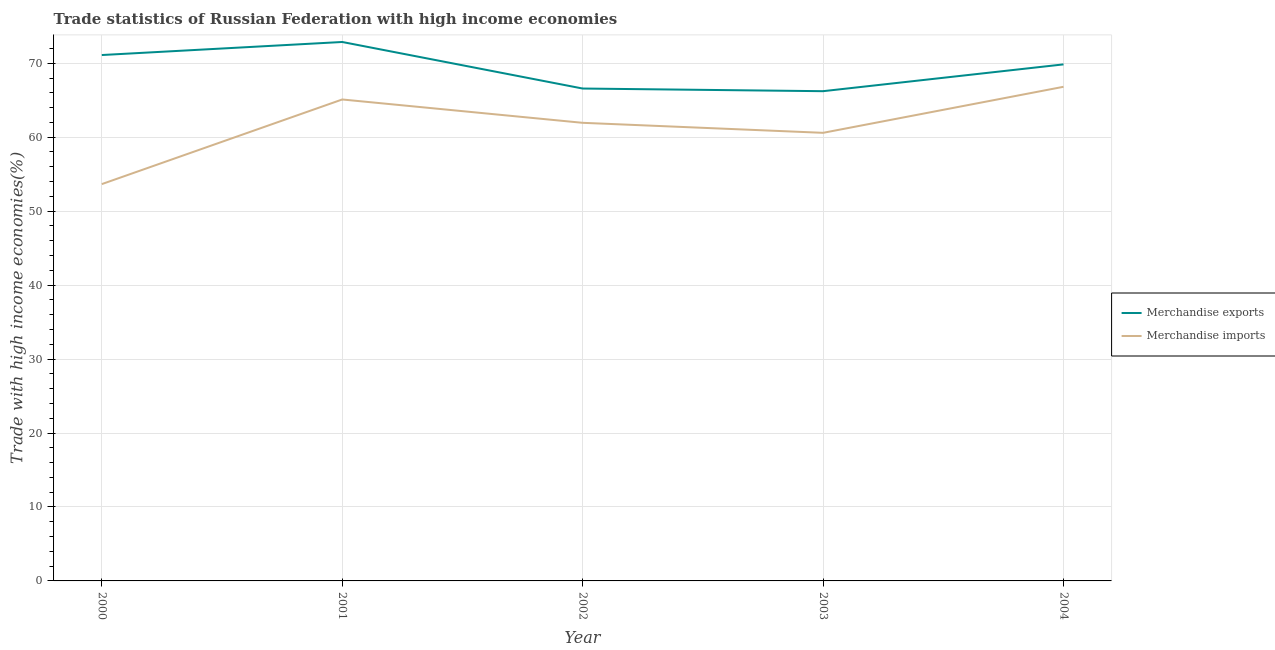How many different coloured lines are there?
Give a very brief answer. 2. What is the merchandise exports in 2002?
Your response must be concise. 66.58. Across all years, what is the maximum merchandise exports?
Your answer should be compact. 72.87. Across all years, what is the minimum merchandise imports?
Offer a terse response. 53.65. In which year was the merchandise exports maximum?
Your answer should be compact. 2001. What is the total merchandise imports in the graph?
Your answer should be very brief. 308.09. What is the difference between the merchandise exports in 2001 and that in 2004?
Keep it short and to the point. 3.03. What is the difference between the merchandise imports in 2000 and the merchandise exports in 2001?
Ensure brevity in your answer.  -19.22. What is the average merchandise imports per year?
Offer a very short reply. 61.62. In the year 2001, what is the difference between the merchandise exports and merchandise imports?
Make the answer very short. 7.77. In how many years, is the merchandise imports greater than 22 %?
Offer a very short reply. 5. What is the ratio of the merchandise imports in 2001 to that in 2004?
Provide a short and direct response. 0.97. Is the merchandise exports in 2000 less than that in 2003?
Ensure brevity in your answer.  No. What is the difference between the highest and the second highest merchandise exports?
Keep it short and to the point. 1.76. What is the difference between the highest and the lowest merchandise imports?
Your response must be concise. 13.16. Does the merchandise exports monotonically increase over the years?
Keep it short and to the point. No. Is the merchandise imports strictly greater than the merchandise exports over the years?
Make the answer very short. No. Is the merchandise imports strictly less than the merchandise exports over the years?
Provide a succinct answer. Yes. What is the difference between two consecutive major ticks on the Y-axis?
Keep it short and to the point. 10. Where does the legend appear in the graph?
Your response must be concise. Center right. How many legend labels are there?
Offer a terse response. 2. What is the title of the graph?
Ensure brevity in your answer.  Trade statistics of Russian Federation with high income economies. What is the label or title of the X-axis?
Offer a terse response. Year. What is the label or title of the Y-axis?
Your answer should be compact. Trade with high income economies(%). What is the Trade with high income economies(%) of Merchandise exports in 2000?
Provide a succinct answer. 71.11. What is the Trade with high income economies(%) of Merchandise imports in 2000?
Provide a succinct answer. 53.65. What is the Trade with high income economies(%) in Merchandise exports in 2001?
Your answer should be very brief. 72.87. What is the Trade with high income economies(%) of Merchandise imports in 2001?
Give a very brief answer. 65.1. What is the Trade with high income economies(%) of Merchandise exports in 2002?
Provide a succinct answer. 66.58. What is the Trade with high income economies(%) in Merchandise imports in 2002?
Your response must be concise. 61.94. What is the Trade with high income economies(%) in Merchandise exports in 2003?
Your answer should be very brief. 66.22. What is the Trade with high income economies(%) of Merchandise imports in 2003?
Your answer should be compact. 60.59. What is the Trade with high income economies(%) of Merchandise exports in 2004?
Give a very brief answer. 69.84. What is the Trade with high income economies(%) of Merchandise imports in 2004?
Make the answer very short. 66.81. Across all years, what is the maximum Trade with high income economies(%) in Merchandise exports?
Provide a succinct answer. 72.87. Across all years, what is the maximum Trade with high income economies(%) of Merchandise imports?
Your response must be concise. 66.81. Across all years, what is the minimum Trade with high income economies(%) in Merchandise exports?
Provide a short and direct response. 66.22. Across all years, what is the minimum Trade with high income economies(%) of Merchandise imports?
Offer a terse response. 53.65. What is the total Trade with high income economies(%) in Merchandise exports in the graph?
Make the answer very short. 346.61. What is the total Trade with high income economies(%) of Merchandise imports in the graph?
Provide a succinct answer. 308.09. What is the difference between the Trade with high income economies(%) of Merchandise exports in 2000 and that in 2001?
Offer a terse response. -1.76. What is the difference between the Trade with high income economies(%) of Merchandise imports in 2000 and that in 2001?
Make the answer very short. -11.44. What is the difference between the Trade with high income economies(%) of Merchandise exports in 2000 and that in 2002?
Provide a succinct answer. 4.53. What is the difference between the Trade with high income economies(%) of Merchandise imports in 2000 and that in 2002?
Offer a very short reply. -8.29. What is the difference between the Trade with high income economies(%) of Merchandise exports in 2000 and that in 2003?
Ensure brevity in your answer.  4.89. What is the difference between the Trade with high income economies(%) of Merchandise imports in 2000 and that in 2003?
Your response must be concise. -6.93. What is the difference between the Trade with high income economies(%) of Merchandise exports in 2000 and that in 2004?
Your response must be concise. 1.27. What is the difference between the Trade with high income economies(%) in Merchandise imports in 2000 and that in 2004?
Ensure brevity in your answer.  -13.16. What is the difference between the Trade with high income economies(%) in Merchandise exports in 2001 and that in 2002?
Make the answer very short. 6.29. What is the difference between the Trade with high income economies(%) in Merchandise imports in 2001 and that in 2002?
Your answer should be very brief. 3.16. What is the difference between the Trade with high income economies(%) in Merchandise exports in 2001 and that in 2003?
Offer a very short reply. 6.65. What is the difference between the Trade with high income economies(%) in Merchandise imports in 2001 and that in 2003?
Provide a short and direct response. 4.51. What is the difference between the Trade with high income economies(%) of Merchandise exports in 2001 and that in 2004?
Make the answer very short. 3.03. What is the difference between the Trade with high income economies(%) of Merchandise imports in 2001 and that in 2004?
Keep it short and to the point. -1.72. What is the difference between the Trade with high income economies(%) of Merchandise exports in 2002 and that in 2003?
Give a very brief answer. 0.36. What is the difference between the Trade with high income economies(%) of Merchandise imports in 2002 and that in 2003?
Make the answer very short. 1.35. What is the difference between the Trade with high income economies(%) of Merchandise exports in 2002 and that in 2004?
Offer a terse response. -3.26. What is the difference between the Trade with high income economies(%) in Merchandise imports in 2002 and that in 2004?
Keep it short and to the point. -4.87. What is the difference between the Trade with high income economies(%) of Merchandise exports in 2003 and that in 2004?
Ensure brevity in your answer.  -3.62. What is the difference between the Trade with high income economies(%) of Merchandise imports in 2003 and that in 2004?
Ensure brevity in your answer.  -6.22. What is the difference between the Trade with high income economies(%) in Merchandise exports in 2000 and the Trade with high income economies(%) in Merchandise imports in 2001?
Your answer should be compact. 6.01. What is the difference between the Trade with high income economies(%) in Merchandise exports in 2000 and the Trade with high income economies(%) in Merchandise imports in 2002?
Make the answer very short. 9.17. What is the difference between the Trade with high income economies(%) of Merchandise exports in 2000 and the Trade with high income economies(%) of Merchandise imports in 2003?
Offer a very short reply. 10.52. What is the difference between the Trade with high income economies(%) in Merchandise exports in 2000 and the Trade with high income economies(%) in Merchandise imports in 2004?
Ensure brevity in your answer.  4.29. What is the difference between the Trade with high income economies(%) in Merchandise exports in 2001 and the Trade with high income economies(%) in Merchandise imports in 2002?
Keep it short and to the point. 10.93. What is the difference between the Trade with high income economies(%) of Merchandise exports in 2001 and the Trade with high income economies(%) of Merchandise imports in 2003?
Keep it short and to the point. 12.28. What is the difference between the Trade with high income economies(%) of Merchandise exports in 2001 and the Trade with high income economies(%) of Merchandise imports in 2004?
Offer a very short reply. 6.06. What is the difference between the Trade with high income economies(%) in Merchandise exports in 2002 and the Trade with high income economies(%) in Merchandise imports in 2003?
Provide a short and direct response. 5.99. What is the difference between the Trade with high income economies(%) in Merchandise exports in 2002 and the Trade with high income economies(%) in Merchandise imports in 2004?
Your response must be concise. -0.24. What is the difference between the Trade with high income economies(%) in Merchandise exports in 2003 and the Trade with high income economies(%) in Merchandise imports in 2004?
Make the answer very short. -0.59. What is the average Trade with high income economies(%) in Merchandise exports per year?
Your answer should be compact. 69.32. What is the average Trade with high income economies(%) in Merchandise imports per year?
Give a very brief answer. 61.62. In the year 2000, what is the difference between the Trade with high income economies(%) of Merchandise exports and Trade with high income economies(%) of Merchandise imports?
Ensure brevity in your answer.  17.45. In the year 2001, what is the difference between the Trade with high income economies(%) in Merchandise exports and Trade with high income economies(%) in Merchandise imports?
Your answer should be very brief. 7.77. In the year 2002, what is the difference between the Trade with high income economies(%) of Merchandise exports and Trade with high income economies(%) of Merchandise imports?
Give a very brief answer. 4.64. In the year 2003, what is the difference between the Trade with high income economies(%) of Merchandise exports and Trade with high income economies(%) of Merchandise imports?
Keep it short and to the point. 5.63. In the year 2004, what is the difference between the Trade with high income economies(%) in Merchandise exports and Trade with high income economies(%) in Merchandise imports?
Make the answer very short. 3.03. What is the ratio of the Trade with high income economies(%) in Merchandise exports in 2000 to that in 2001?
Your answer should be very brief. 0.98. What is the ratio of the Trade with high income economies(%) of Merchandise imports in 2000 to that in 2001?
Your answer should be compact. 0.82. What is the ratio of the Trade with high income economies(%) in Merchandise exports in 2000 to that in 2002?
Make the answer very short. 1.07. What is the ratio of the Trade with high income economies(%) of Merchandise imports in 2000 to that in 2002?
Give a very brief answer. 0.87. What is the ratio of the Trade with high income economies(%) of Merchandise exports in 2000 to that in 2003?
Make the answer very short. 1.07. What is the ratio of the Trade with high income economies(%) in Merchandise imports in 2000 to that in 2003?
Your response must be concise. 0.89. What is the ratio of the Trade with high income economies(%) in Merchandise exports in 2000 to that in 2004?
Offer a terse response. 1.02. What is the ratio of the Trade with high income economies(%) of Merchandise imports in 2000 to that in 2004?
Offer a terse response. 0.8. What is the ratio of the Trade with high income economies(%) of Merchandise exports in 2001 to that in 2002?
Your response must be concise. 1.09. What is the ratio of the Trade with high income economies(%) in Merchandise imports in 2001 to that in 2002?
Your response must be concise. 1.05. What is the ratio of the Trade with high income economies(%) in Merchandise exports in 2001 to that in 2003?
Offer a very short reply. 1.1. What is the ratio of the Trade with high income economies(%) in Merchandise imports in 2001 to that in 2003?
Ensure brevity in your answer.  1.07. What is the ratio of the Trade with high income economies(%) of Merchandise exports in 2001 to that in 2004?
Provide a succinct answer. 1.04. What is the ratio of the Trade with high income economies(%) in Merchandise imports in 2001 to that in 2004?
Offer a terse response. 0.97. What is the ratio of the Trade with high income economies(%) of Merchandise exports in 2002 to that in 2003?
Make the answer very short. 1.01. What is the ratio of the Trade with high income economies(%) of Merchandise imports in 2002 to that in 2003?
Your answer should be compact. 1.02. What is the ratio of the Trade with high income economies(%) in Merchandise exports in 2002 to that in 2004?
Offer a terse response. 0.95. What is the ratio of the Trade with high income economies(%) in Merchandise imports in 2002 to that in 2004?
Offer a terse response. 0.93. What is the ratio of the Trade with high income economies(%) in Merchandise exports in 2003 to that in 2004?
Offer a very short reply. 0.95. What is the ratio of the Trade with high income economies(%) in Merchandise imports in 2003 to that in 2004?
Your answer should be very brief. 0.91. What is the difference between the highest and the second highest Trade with high income economies(%) of Merchandise exports?
Your response must be concise. 1.76. What is the difference between the highest and the second highest Trade with high income economies(%) in Merchandise imports?
Offer a terse response. 1.72. What is the difference between the highest and the lowest Trade with high income economies(%) of Merchandise exports?
Provide a short and direct response. 6.65. What is the difference between the highest and the lowest Trade with high income economies(%) in Merchandise imports?
Your response must be concise. 13.16. 